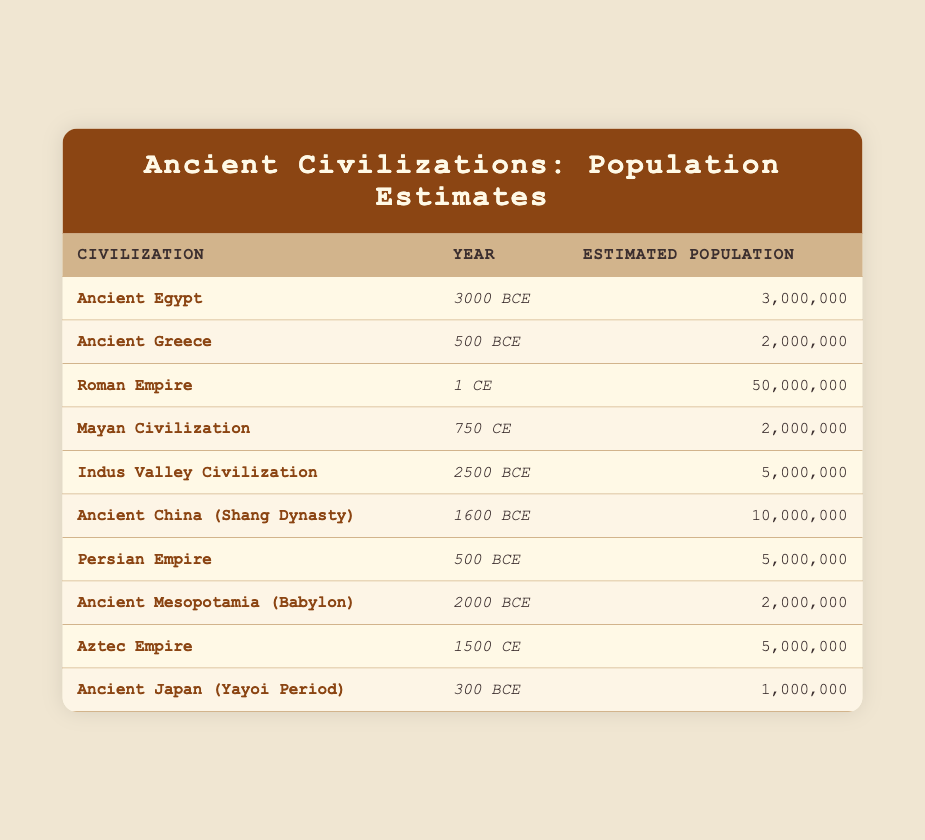What was the estimated population of Ancient Egypt in 3000 BCE? According to the table, the estimated population of Ancient Egypt in 3000 BCE is clearly stated as 3,000,000.
Answer: 3,000,000 How many civilizations had an estimated population greater than 5 million? By reviewing the table, we observe that the Roman Empire (50,000,000), Indus Valley Civilization (5,000,000), and Ancient China (10,000,000) have populations greater than 5 million. This totals to four civilizations.
Answer: 4 Is the estimated population of the Aztec Empire in 1500 CE higher than that of the Ancient Greece in 500 BCE? Looking at the table, the Aztec Empire's estimated population is 5,000,000, while Ancient Greece is recorded at 2,000,000. Since 5,000,000 is greater than 2,000,000, the statement is true.
Answer: Yes What is the total estimated population of the civilizations listed for the year 500 BCE? From the table, the civilizations listed for 500 BCE are Ancient Greece (2,000,000) and Persian Empire (5,000,000). Adding these populations together gives 2,000,000 + 5,000,000 = 7,000,000.
Answer: 7,000,000 Which civilization listed has the highest estimated population, and what is that population? Upon scanning the table, the Roman Empire has the highest estimated population listed, which is 50,000,000.
Answer: Roman Empire, 50,000,000 What is the difference in estimated population between the Ancient China (Shang Dynasty) and the Indus Valley Civilization? The estimated population of Ancient China is 10,000,000, and for the Indus Valley Civilization, it is 5,000,000. The difference can be calculated as 10,000,000 - 5,000,000 = 5,000,000.
Answer: 5,000,000 Did the Ancient Japan (Yayoi Period) have a higher estimated population than the Mayan Civilization? The estimated population of Ancient Japan is 1,000,000, while the Mayan Civilization stands at 2,000,000. Since 1,000,000 is less than 2,000,000, the statement is false.
Answer: No What is the average estimated population of the civilizations listed for the year 1 CE? The table shows only one civilization for 1 CE, which is the Roman Empire with an estimated population of 50,000,000. Therefore, the average population is simply 50,000,000 since it's the only entry.
Answer: 50,000,000 